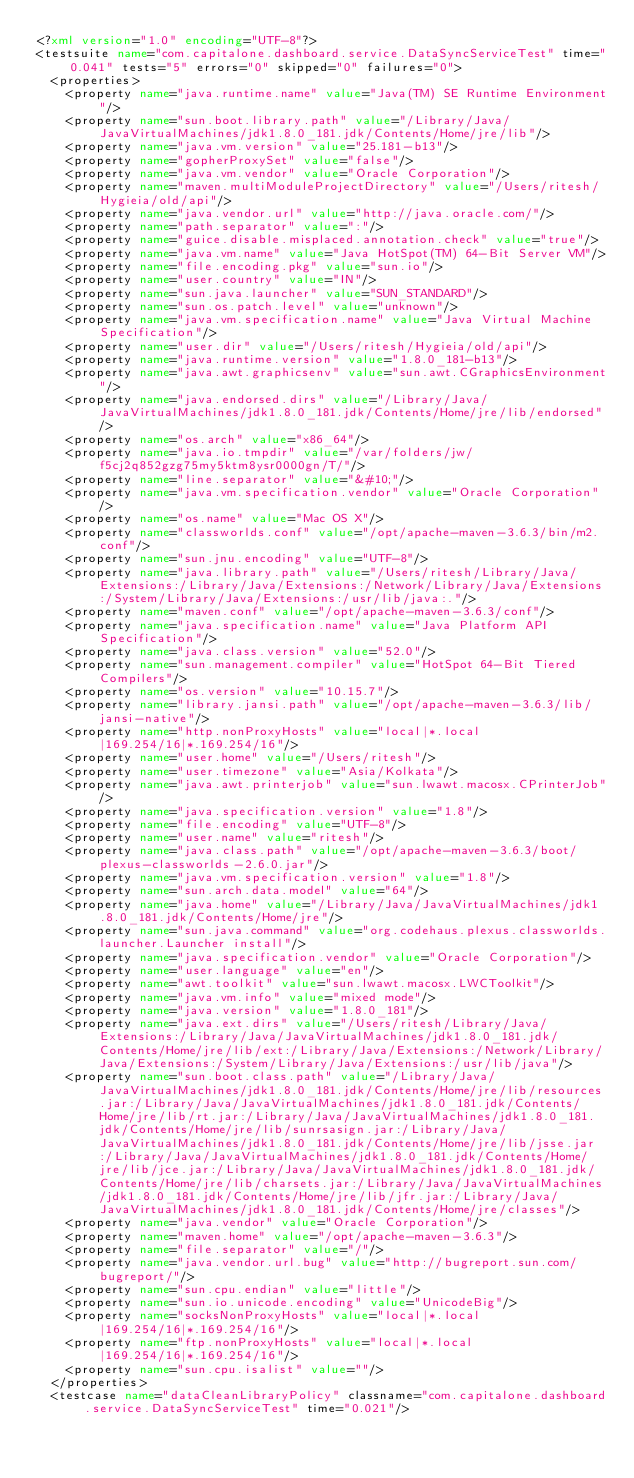<code> <loc_0><loc_0><loc_500><loc_500><_XML_><?xml version="1.0" encoding="UTF-8"?>
<testsuite name="com.capitalone.dashboard.service.DataSyncServiceTest" time="0.041" tests="5" errors="0" skipped="0" failures="0">
  <properties>
    <property name="java.runtime.name" value="Java(TM) SE Runtime Environment"/>
    <property name="sun.boot.library.path" value="/Library/Java/JavaVirtualMachines/jdk1.8.0_181.jdk/Contents/Home/jre/lib"/>
    <property name="java.vm.version" value="25.181-b13"/>
    <property name="gopherProxySet" value="false"/>
    <property name="java.vm.vendor" value="Oracle Corporation"/>
    <property name="maven.multiModuleProjectDirectory" value="/Users/ritesh/Hygieia/old/api"/>
    <property name="java.vendor.url" value="http://java.oracle.com/"/>
    <property name="path.separator" value=":"/>
    <property name="guice.disable.misplaced.annotation.check" value="true"/>
    <property name="java.vm.name" value="Java HotSpot(TM) 64-Bit Server VM"/>
    <property name="file.encoding.pkg" value="sun.io"/>
    <property name="user.country" value="IN"/>
    <property name="sun.java.launcher" value="SUN_STANDARD"/>
    <property name="sun.os.patch.level" value="unknown"/>
    <property name="java.vm.specification.name" value="Java Virtual Machine Specification"/>
    <property name="user.dir" value="/Users/ritesh/Hygieia/old/api"/>
    <property name="java.runtime.version" value="1.8.0_181-b13"/>
    <property name="java.awt.graphicsenv" value="sun.awt.CGraphicsEnvironment"/>
    <property name="java.endorsed.dirs" value="/Library/Java/JavaVirtualMachines/jdk1.8.0_181.jdk/Contents/Home/jre/lib/endorsed"/>
    <property name="os.arch" value="x86_64"/>
    <property name="java.io.tmpdir" value="/var/folders/jw/f5cj2q852gzg75my5ktm8ysr0000gn/T/"/>
    <property name="line.separator" value="&#10;"/>
    <property name="java.vm.specification.vendor" value="Oracle Corporation"/>
    <property name="os.name" value="Mac OS X"/>
    <property name="classworlds.conf" value="/opt/apache-maven-3.6.3/bin/m2.conf"/>
    <property name="sun.jnu.encoding" value="UTF-8"/>
    <property name="java.library.path" value="/Users/ritesh/Library/Java/Extensions:/Library/Java/Extensions:/Network/Library/Java/Extensions:/System/Library/Java/Extensions:/usr/lib/java:."/>
    <property name="maven.conf" value="/opt/apache-maven-3.6.3/conf"/>
    <property name="java.specification.name" value="Java Platform API Specification"/>
    <property name="java.class.version" value="52.0"/>
    <property name="sun.management.compiler" value="HotSpot 64-Bit Tiered Compilers"/>
    <property name="os.version" value="10.15.7"/>
    <property name="library.jansi.path" value="/opt/apache-maven-3.6.3/lib/jansi-native"/>
    <property name="http.nonProxyHosts" value="local|*.local|169.254/16|*.169.254/16"/>
    <property name="user.home" value="/Users/ritesh"/>
    <property name="user.timezone" value="Asia/Kolkata"/>
    <property name="java.awt.printerjob" value="sun.lwawt.macosx.CPrinterJob"/>
    <property name="java.specification.version" value="1.8"/>
    <property name="file.encoding" value="UTF-8"/>
    <property name="user.name" value="ritesh"/>
    <property name="java.class.path" value="/opt/apache-maven-3.6.3/boot/plexus-classworlds-2.6.0.jar"/>
    <property name="java.vm.specification.version" value="1.8"/>
    <property name="sun.arch.data.model" value="64"/>
    <property name="java.home" value="/Library/Java/JavaVirtualMachines/jdk1.8.0_181.jdk/Contents/Home/jre"/>
    <property name="sun.java.command" value="org.codehaus.plexus.classworlds.launcher.Launcher install"/>
    <property name="java.specification.vendor" value="Oracle Corporation"/>
    <property name="user.language" value="en"/>
    <property name="awt.toolkit" value="sun.lwawt.macosx.LWCToolkit"/>
    <property name="java.vm.info" value="mixed mode"/>
    <property name="java.version" value="1.8.0_181"/>
    <property name="java.ext.dirs" value="/Users/ritesh/Library/Java/Extensions:/Library/Java/JavaVirtualMachines/jdk1.8.0_181.jdk/Contents/Home/jre/lib/ext:/Library/Java/Extensions:/Network/Library/Java/Extensions:/System/Library/Java/Extensions:/usr/lib/java"/>
    <property name="sun.boot.class.path" value="/Library/Java/JavaVirtualMachines/jdk1.8.0_181.jdk/Contents/Home/jre/lib/resources.jar:/Library/Java/JavaVirtualMachines/jdk1.8.0_181.jdk/Contents/Home/jre/lib/rt.jar:/Library/Java/JavaVirtualMachines/jdk1.8.0_181.jdk/Contents/Home/jre/lib/sunrsasign.jar:/Library/Java/JavaVirtualMachines/jdk1.8.0_181.jdk/Contents/Home/jre/lib/jsse.jar:/Library/Java/JavaVirtualMachines/jdk1.8.0_181.jdk/Contents/Home/jre/lib/jce.jar:/Library/Java/JavaVirtualMachines/jdk1.8.0_181.jdk/Contents/Home/jre/lib/charsets.jar:/Library/Java/JavaVirtualMachines/jdk1.8.0_181.jdk/Contents/Home/jre/lib/jfr.jar:/Library/Java/JavaVirtualMachines/jdk1.8.0_181.jdk/Contents/Home/jre/classes"/>
    <property name="java.vendor" value="Oracle Corporation"/>
    <property name="maven.home" value="/opt/apache-maven-3.6.3"/>
    <property name="file.separator" value="/"/>
    <property name="java.vendor.url.bug" value="http://bugreport.sun.com/bugreport/"/>
    <property name="sun.cpu.endian" value="little"/>
    <property name="sun.io.unicode.encoding" value="UnicodeBig"/>
    <property name="socksNonProxyHosts" value="local|*.local|169.254/16|*.169.254/16"/>
    <property name="ftp.nonProxyHosts" value="local|*.local|169.254/16|*.169.254/16"/>
    <property name="sun.cpu.isalist" value=""/>
  </properties>
  <testcase name="dataCleanLibraryPolicy" classname="com.capitalone.dashboard.service.DataSyncServiceTest" time="0.021"/></code> 